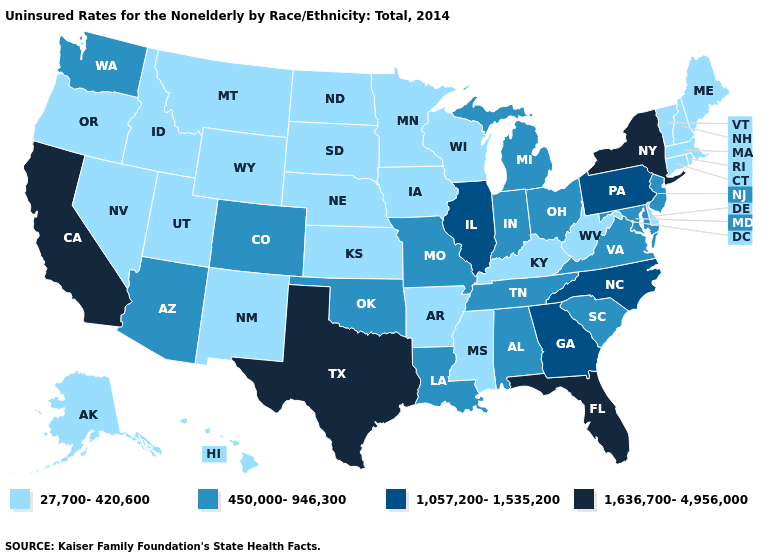What is the value of Colorado?
Concise answer only. 450,000-946,300. How many symbols are there in the legend?
Give a very brief answer. 4. Name the states that have a value in the range 450,000-946,300?
Short answer required. Alabama, Arizona, Colorado, Indiana, Louisiana, Maryland, Michigan, Missouri, New Jersey, Ohio, Oklahoma, South Carolina, Tennessee, Virginia, Washington. Which states hav the highest value in the South?
Quick response, please. Florida, Texas. What is the value of New Jersey?
Concise answer only. 450,000-946,300. What is the highest value in the Northeast ?
Be succinct. 1,636,700-4,956,000. Among the states that border Mississippi , does Tennessee have the highest value?
Be succinct. Yes. What is the value of Idaho?
Write a very short answer. 27,700-420,600. How many symbols are there in the legend?
Answer briefly. 4. Among the states that border Tennessee , does Georgia have the highest value?
Short answer required. Yes. Does Vermont have the same value as Massachusetts?
Give a very brief answer. Yes. What is the value of New Hampshire?
Quick response, please. 27,700-420,600. Does Iowa have the highest value in the USA?
Write a very short answer. No. Does Colorado have the lowest value in the USA?
Be succinct. No. Name the states that have a value in the range 450,000-946,300?
Be succinct. Alabama, Arizona, Colorado, Indiana, Louisiana, Maryland, Michigan, Missouri, New Jersey, Ohio, Oklahoma, South Carolina, Tennessee, Virginia, Washington. 